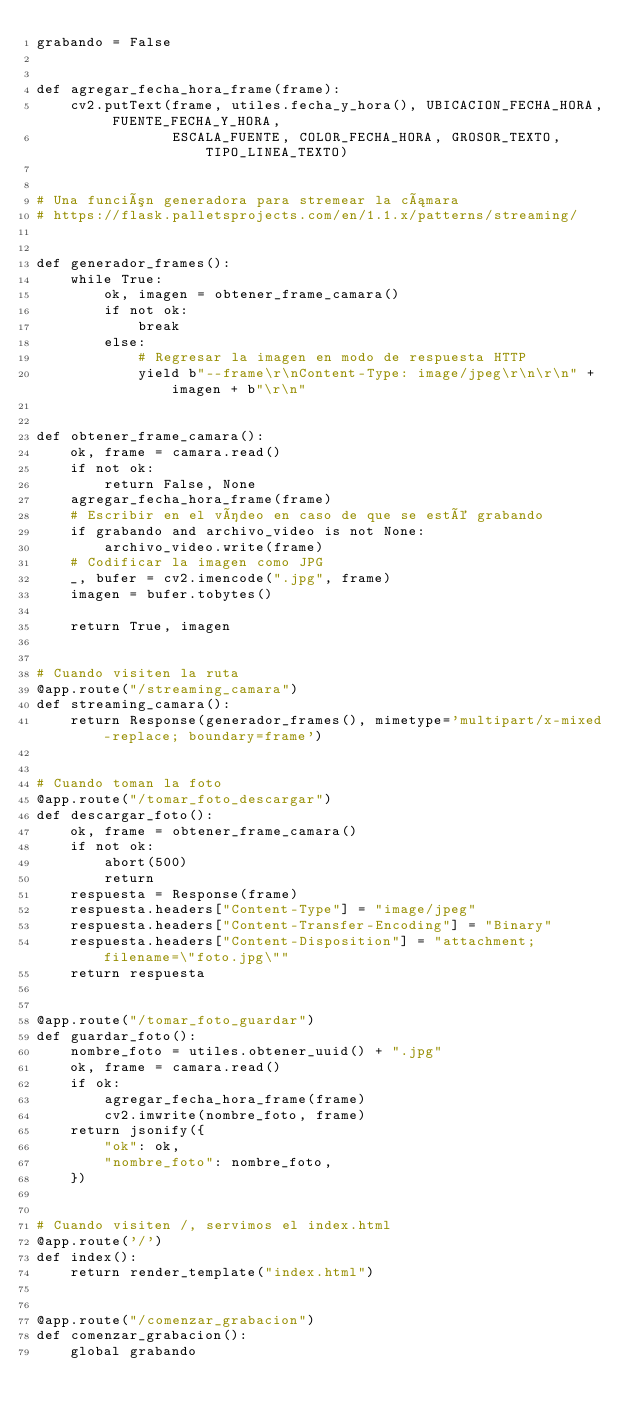<code> <loc_0><loc_0><loc_500><loc_500><_Python_>grabando = False


def agregar_fecha_hora_frame(frame):
    cv2.putText(frame, utiles.fecha_y_hora(), UBICACION_FECHA_HORA, FUENTE_FECHA_Y_HORA,
                ESCALA_FUENTE, COLOR_FECHA_HORA, GROSOR_TEXTO, TIPO_LINEA_TEXTO)


# Una función generadora para stremear la cámara
# https://flask.palletsprojects.com/en/1.1.x/patterns/streaming/


def generador_frames():
    while True:
        ok, imagen = obtener_frame_camara()
        if not ok:
            break
        else:
            # Regresar la imagen en modo de respuesta HTTP
            yield b"--frame\r\nContent-Type: image/jpeg\r\n\r\n" + imagen + b"\r\n"


def obtener_frame_camara():
    ok, frame = camara.read()
    if not ok:
        return False, None
    agregar_fecha_hora_frame(frame)
    # Escribir en el vídeo en caso de que se esté grabando
    if grabando and archivo_video is not None:
        archivo_video.write(frame)
    # Codificar la imagen como JPG
    _, bufer = cv2.imencode(".jpg", frame)
    imagen = bufer.tobytes()

    return True, imagen


# Cuando visiten la ruta
@app.route("/streaming_camara")
def streaming_camara():
    return Response(generador_frames(), mimetype='multipart/x-mixed-replace; boundary=frame')


# Cuando toman la foto
@app.route("/tomar_foto_descargar")
def descargar_foto():
    ok, frame = obtener_frame_camara()
    if not ok:
        abort(500)
        return
    respuesta = Response(frame)
    respuesta.headers["Content-Type"] = "image/jpeg"
    respuesta.headers["Content-Transfer-Encoding"] = "Binary"
    respuesta.headers["Content-Disposition"] = "attachment; filename=\"foto.jpg\""
    return respuesta


@app.route("/tomar_foto_guardar")
def guardar_foto():
    nombre_foto = utiles.obtener_uuid() + ".jpg"
    ok, frame = camara.read()
    if ok:
        agregar_fecha_hora_frame(frame)
        cv2.imwrite(nombre_foto, frame)
    return jsonify({
        "ok": ok,
        "nombre_foto": nombre_foto,
    })


# Cuando visiten /, servimos el index.html
@app.route('/')
def index():
    return render_template("index.html")


@app.route("/comenzar_grabacion")
def comenzar_grabacion():
    global grabando</code> 